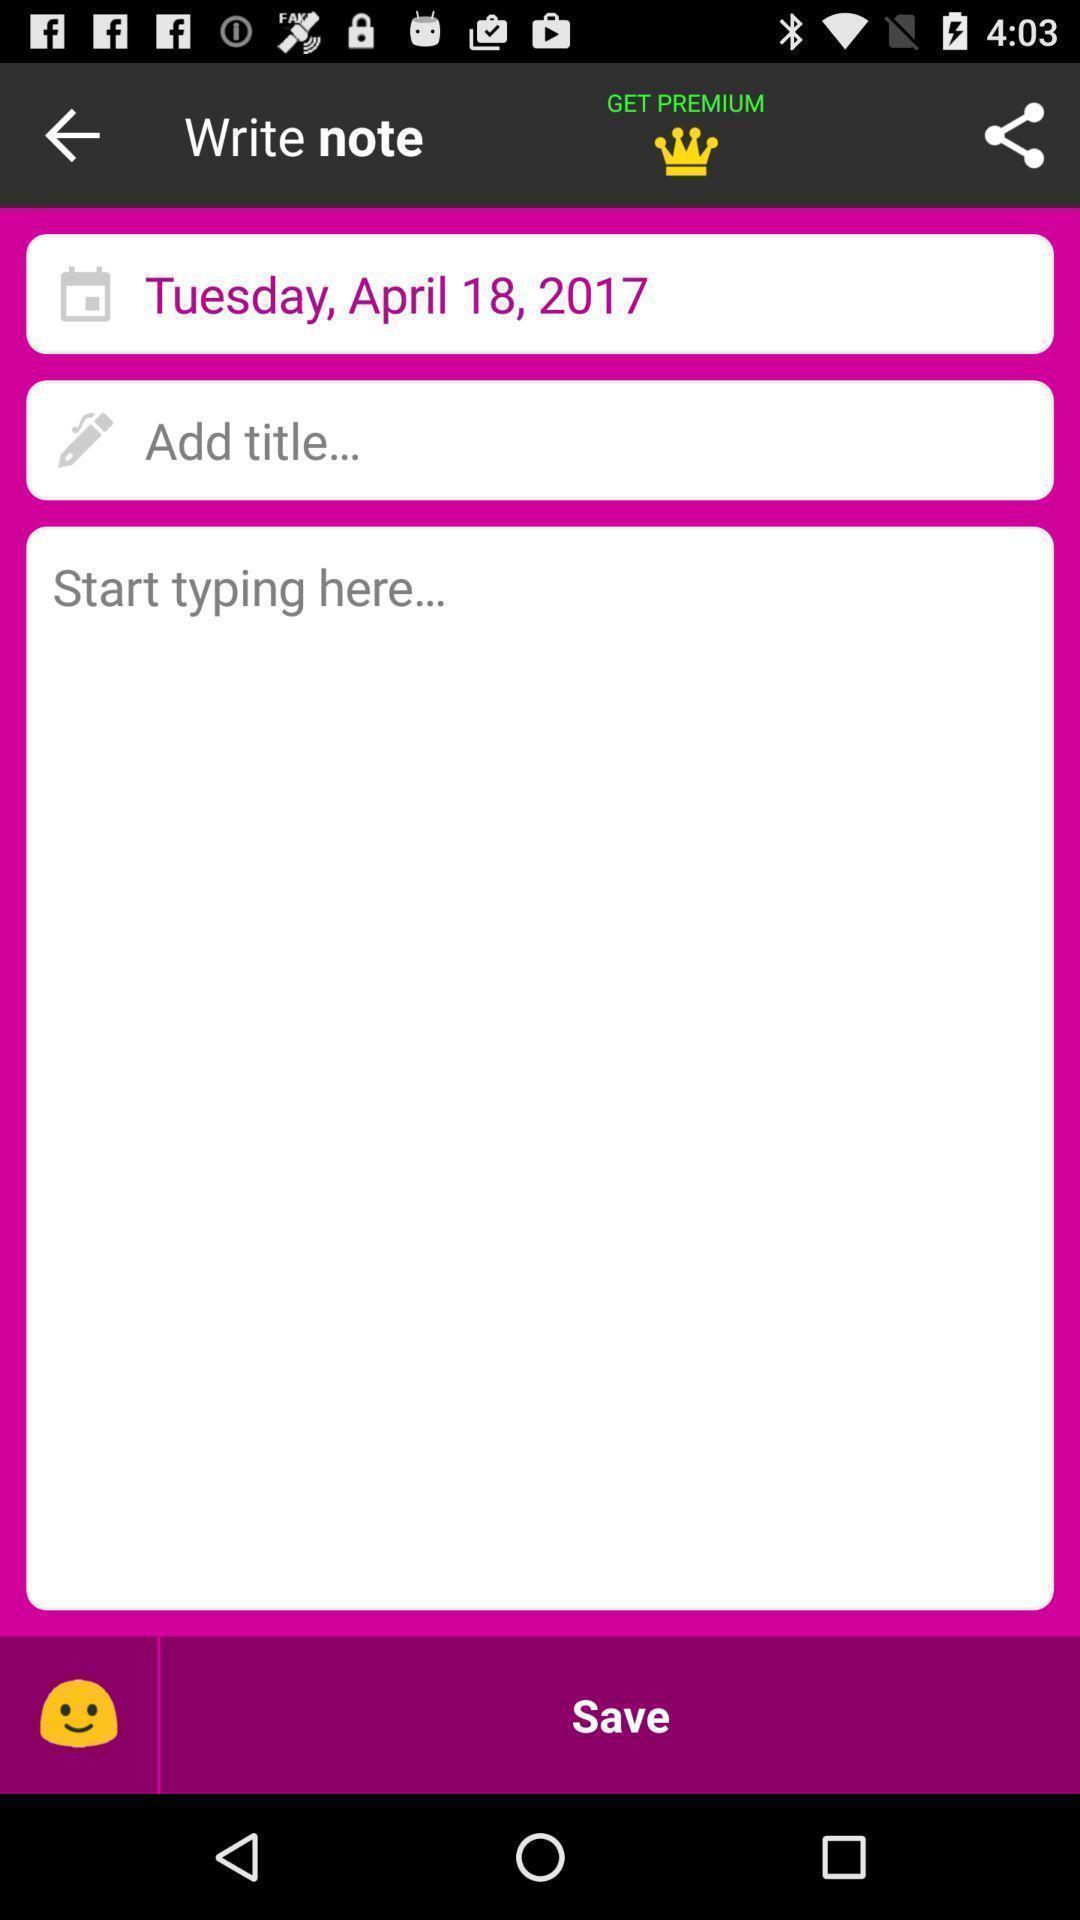Give me a summary of this screen capture. Screen displaying the notes page. 